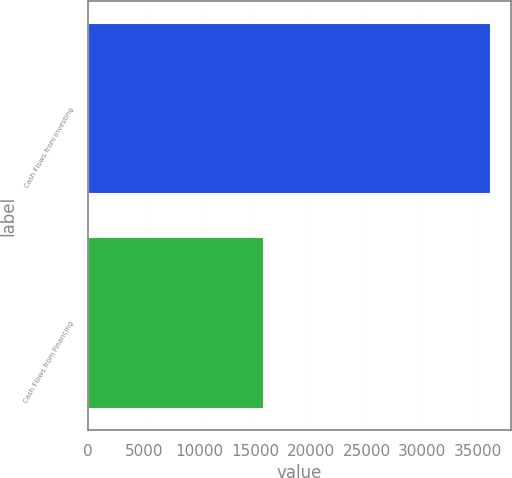Convert chart. <chart><loc_0><loc_0><loc_500><loc_500><bar_chart><fcel>Cash Flows from Investing<fcel>Cash Flows from Financing<nl><fcel>36162<fcel>15803<nl></chart> 